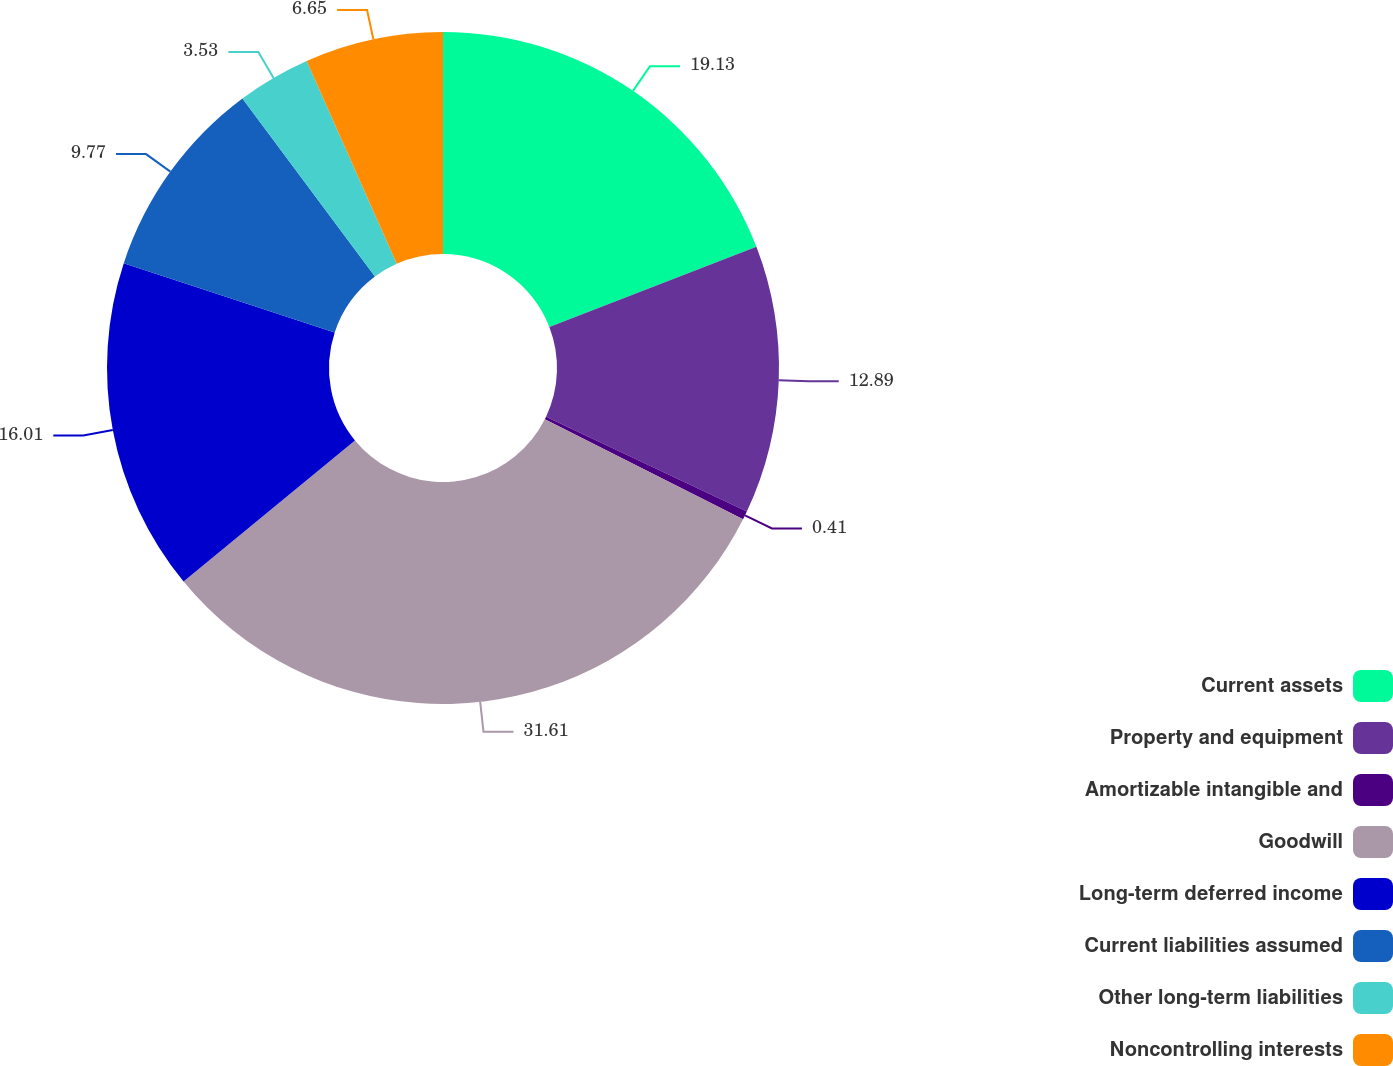<chart> <loc_0><loc_0><loc_500><loc_500><pie_chart><fcel>Current assets<fcel>Property and equipment<fcel>Amortizable intangible and<fcel>Goodwill<fcel>Long-term deferred income<fcel>Current liabilities assumed<fcel>Other long-term liabilities<fcel>Noncontrolling interests<nl><fcel>19.13%<fcel>12.89%<fcel>0.41%<fcel>31.61%<fcel>16.01%<fcel>9.77%<fcel>3.53%<fcel>6.65%<nl></chart> 